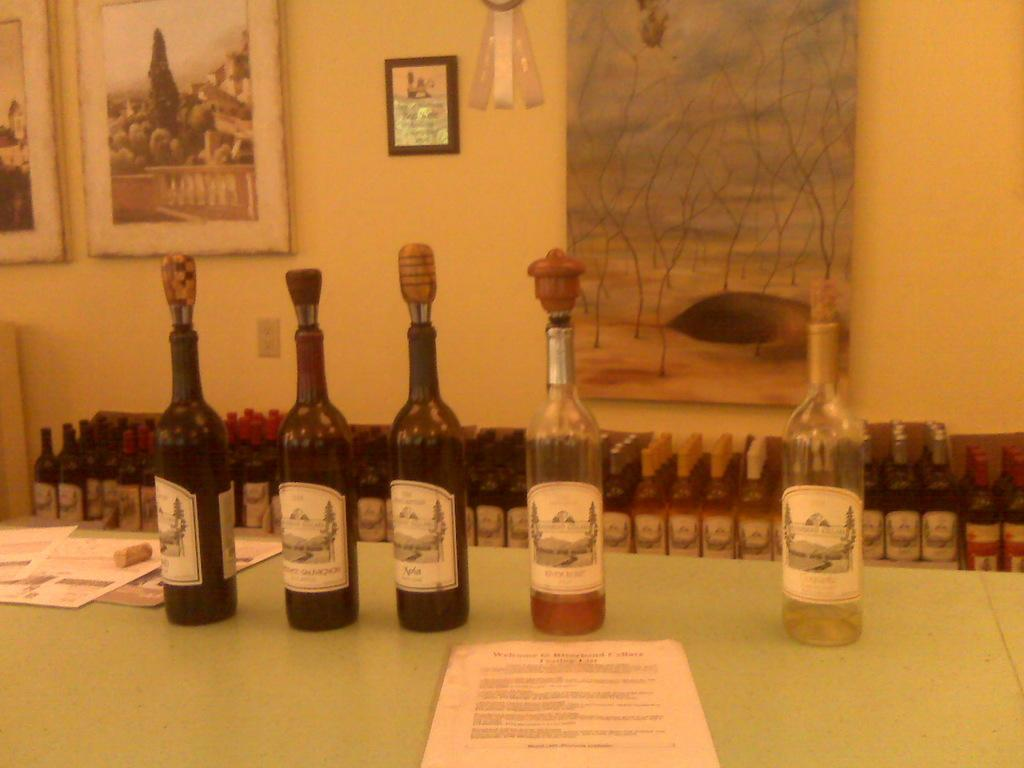Provide a one-sentence caption for the provided image. 5 wine bottles on a table have fancy corks with a Merlot in the center. 